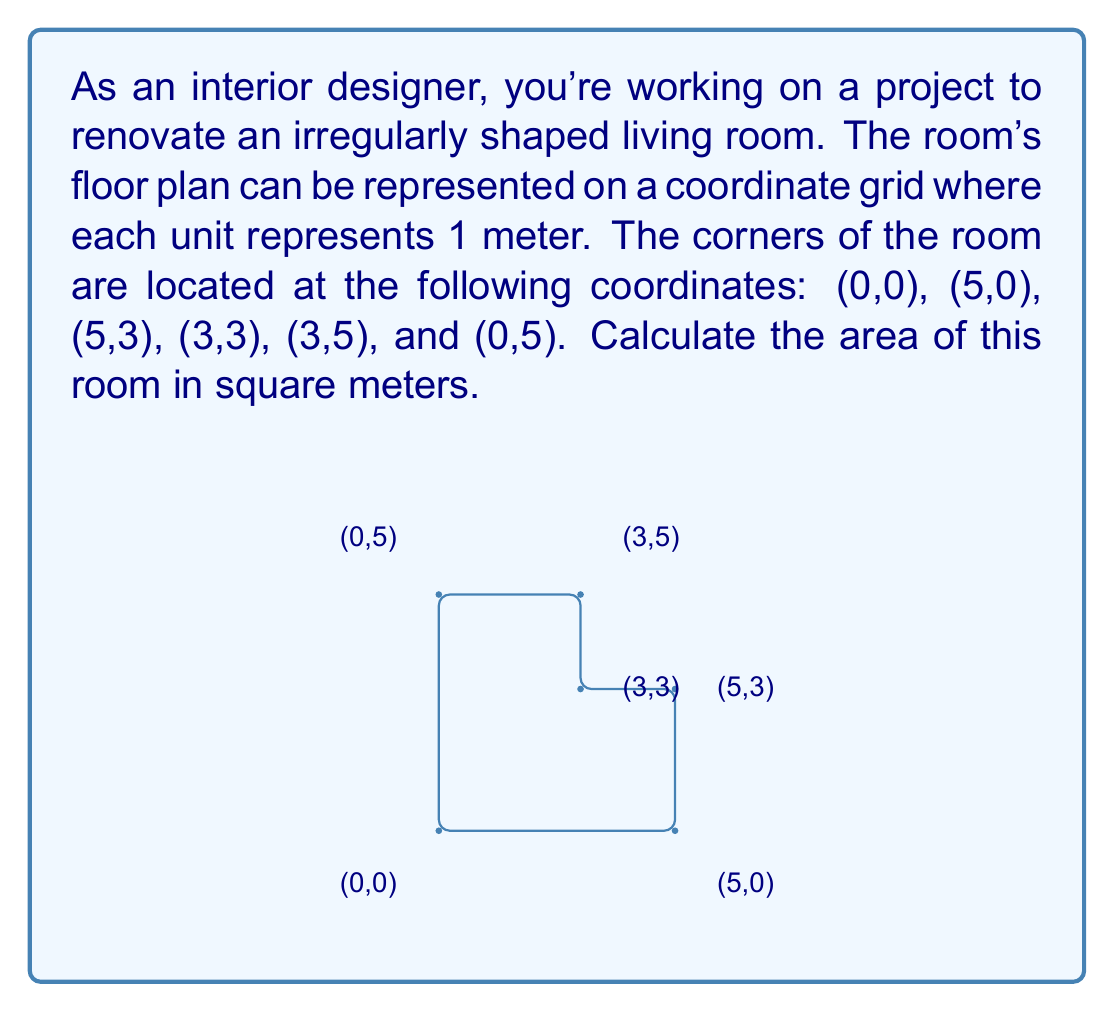Help me with this question. To calculate the area of this irregularly shaped room, we can use the Shoelace formula (also known as the surveyor's formula). This method works for any polygon given the coordinates of its vertices.

The Shoelace formula is:

$$A = \frac{1}{2}|\sum_{i=1}^{n} (x_iy_{i+1} - x_{i+1}y_i)|$$

Where $(x_i, y_i)$ are the coordinates of the $i$-th vertex, and $(x_{n+1}, y_{n+1}) = (x_1, y_1)$.

Let's apply this formula to our room:

1) First, list the coordinates in order:
   (0,0), (5,0), (5,3), (3,3), (3,5), (0,5), (0,0)

2) Now, let's calculate the sum of $x_iy_{i+1}$:
   $0 \cdot 0 + 5 \cdot 3 + 5 \cdot 3 + 3 \cdot 5 + 3 \cdot 5 + 0 \cdot 0 = 45$

3) Next, calculate the sum of $x_{i+1}y_i$:
   $5 \cdot 0 + 5 \cdot 0 + 3 \cdot 3 + 3 \cdot 3 + 0 \cdot 5 + 0 \cdot 0 = 18$

4) Subtract the second sum from the first:
   $45 - 18 = 27$

5) Take the absolute value and divide by 2:
   $\frac{1}{2}|27| = 13.5$

Therefore, the area of the room is 13.5 square meters.
Answer: 13.5 m² 